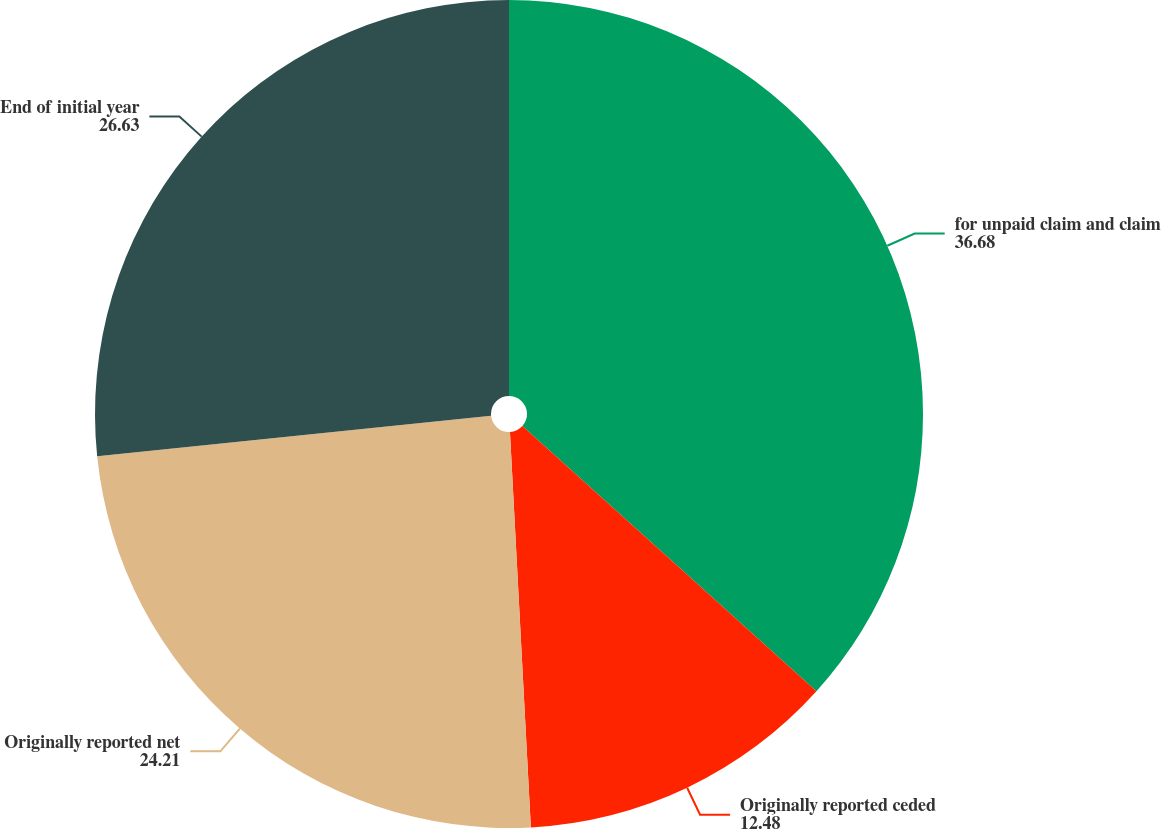Convert chart to OTSL. <chart><loc_0><loc_0><loc_500><loc_500><pie_chart><fcel>for unpaid claim and claim<fcel>Originally reported ceded<fcel>Originally reported net<fcel>End of initial year<nl><fcel>36.68%<fcel>12.48%<fcel>24.21%<fcel>26.63%<nl></chart> 